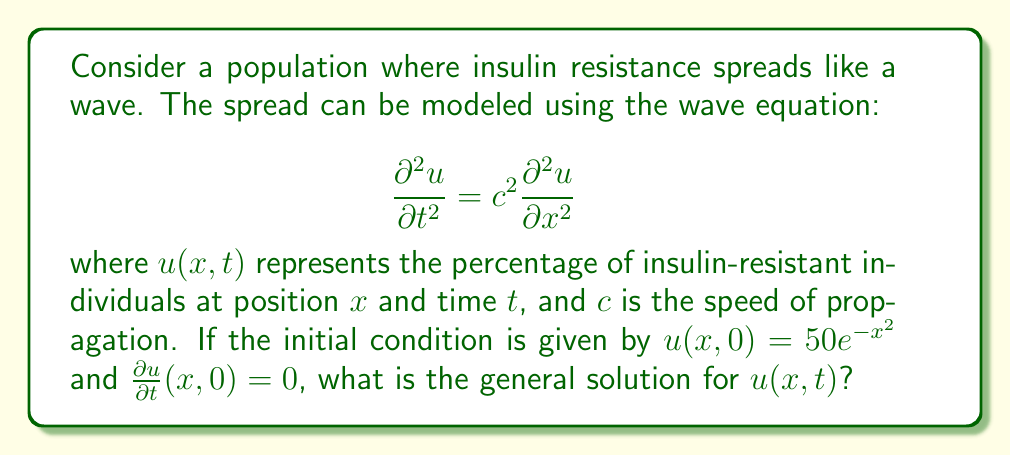Provide a solution to this math problem. To solve this wave equation with the given initial conditions, we'll follow these steps:

1) The general solution to the 1D wave equation is given by d'Alembert's formula:

   $$u(x,t) = \frac{1}{2}[f(x+ct) + f(x-ct)] + \frac{1}{2c}\int_{x-ct}^{x+ct} g(s) ds$$

   where $f(x)$ is the initial displacement and $g(x)$ is the initial velocity.

2) From the initial conditions:
   $f(x) = u(x,0) = 50e^{-x^2}$
   $g(x) = \frac{\partial u}{\partial t}(x,0) = 0$

3) Substituting these into d'Alembert's formula:

   $$u(x,t) = \frac{1}{2}[50e^{-(x+ct)^2} + 50e^{-(x-ct)^2}] + 0$$

4) Simplifying:

   $$u(x,t) = 25[e^{-(x+ct)^2} + e^{-(x-ct)^2}]$$

This is the general solution for $u(x,t)$.
Answer: $u(x,t) = 25[e^{-(x+ct)^2} + e^{-(x-ct)^2}]$ 